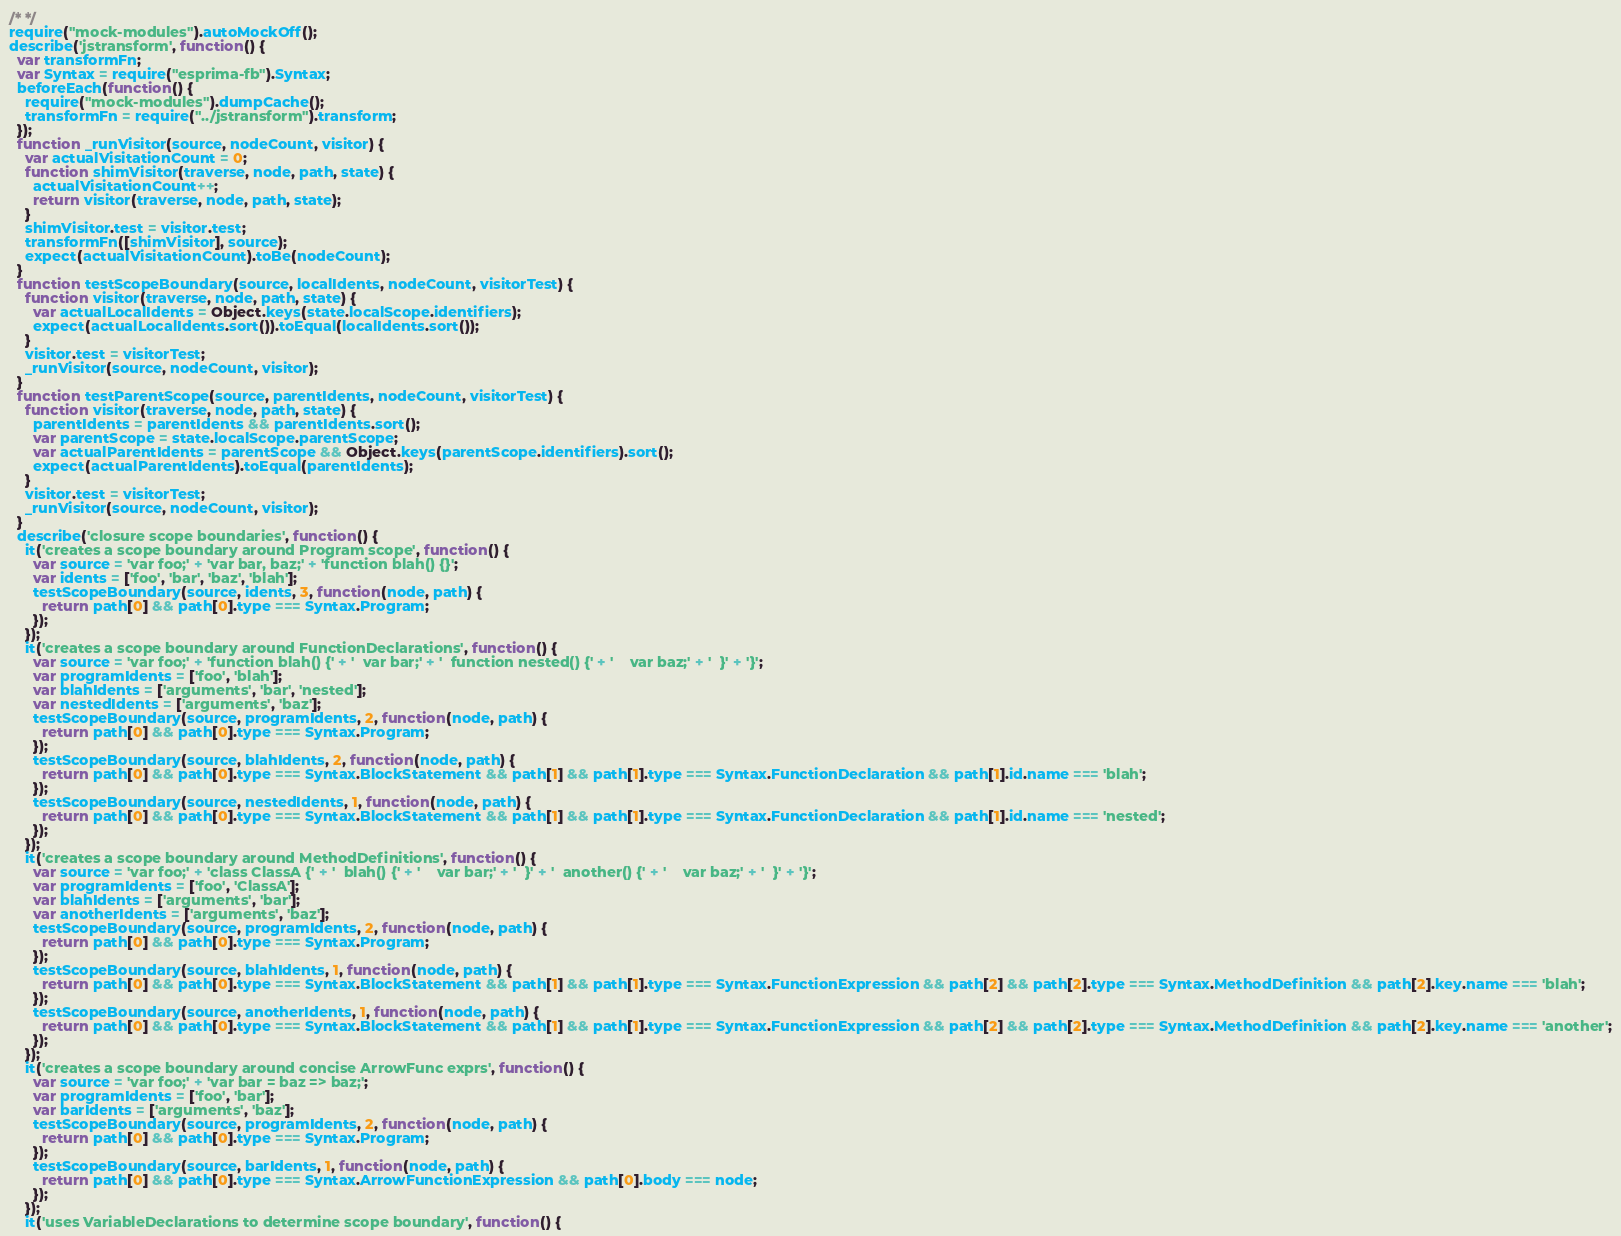Convert code to text. <code><loc_0><loc_0><loc_500><loc_500><_JavaScript_>/* */ 
require("mock-modules").autoMockOff();
describe('jstransform', function() {
  var transformFn;
  var Syntax = require("esprima-fb").Syntax;
  beforeEach(function() {
    require("mock-modules").dumpCache();
    transformFn = require("../jstransform").transform;
  });
  function _runVisitor(source, nodeCount, visitor) {
    var actualVisitationCount = 0;
    function shimVisitor(traverse, node, path, state) {
      actualVisitationCount++;
      return visitor(traverse, node, path, state);
    }
    shimVisitor.test = visitor.test;
    transformFn([shimVisitor], source);
    expect(actualVisitationCount).toBe(nodeCount);
  }
  function testScopeBoundary(source, localIdents, nodeCount, visitorTest) {
    function visitor(traverse, node, path, state) {
      var actualLocalIdents = Object.keys(state.localScope.identifiers);
      expect(actualLocalIdents.sort()).toEqual(localIdents.sort());
    }
    visitor.test = visitorTest;
    _runVisitor(source, nodeCount, visitor);
  }
  function testParentScope(source, parentIdents, nodeCount, visitorTest) {
    function visitor(traverse, node, path, state) {
      parentIdents = parentIdents && parentIdents.sort();
      var parentScope = state.localScope.parentScope;
      var actualParentIdents = parentScope && Object.keys(parentScope.identifiers).sort();
      expect(actualParentIdents).toEqual(parentIdents);
    }
    visitor.test = visitorTest;
    _runVisitor(source, nodeCount, visitor);
  }
  describe('closure scope boundaries', function() {
    it('creates a scope boundary around Program scope', function() {
      var source = 'var foo;' + 'var bar, baz;' + 'function blah() {}';
      var idents = ['foo', 'bar', 'baz', 'blah'];
      testScopeBoundary(source, idents, 3, function(node, path) {
        return path[0] && path[0].type === Syntax.Program;
      });
    });
    it('creates a scope boundary around FunctionDeclarations', function() {
      var source = 'var foo;' + 'function blah() {' + '  var bar;' + '  function nested() {' + '    var baz;' + '  }' + '}';
      var programIdents = ['foo', 'blah'];
      var blahIdents = ['arguments', 'bar', 'nested'];
      var nestedIdents = ['arguments', 'baz'];
      testScopeBoundary(source, programIdents, 2, function(node, path) {
        return path[0] && path[0].type === Syntax.Program;
      });
      testScopeBoundary(source, blahIdents, 2, function(node, path) {
        return path[0] && path[0].type === Syntax.BlockStatement && path[1] && path[1].type === Syntax.FunctionDeclaration && path[1].id.name === 'blah';
      });
      testScopeBoundary(source, nestedIdents, 1, function(node, path) {
        return path[0] && path[0].type === Syntax.BlockStatement && path[1] && path[1].type === Syntax.FunctionDeclaration && path[1].id.name === 'nested';
      });
    });
    it('creates a scope boundary around MethodDefinitions', function() {
      var source = 'var foo;' + 'class ClassA {' + '  blah() {' + '    var bar;' + '  }' + '  another() {' + '    var baz;' + '  }' + '}';
      var programIdents = ['foo', 'ClassA'];
      var blahIdents = ['arguments', 'bar'];
      var anotherIdents = ['arguments', 'baz'];
      testScopeBoundary(source, programIdents, 2, function(node, path) {
        return path[0] && path[0].type === Syntax.Program;
      });
      testScopeBoundary(source, blahIdents, 1, function(node, path) {
        return path[0] && path[0].type === Syntax.BlockStatement && path[1] && path[1].type === Syntax.FunctionExpression && path[2] && path[2].type === Syntax.MethodDefinition && path[2].key.name === 'blah';
      });
      testScopeBoundary(source, anotherIdents, 1, function(node, path) {
        return path[0] && path[0].type === Syntax.BlockStatement && path[1] && path[1].type === Syntax.FunctionExpression && path[2] && path[2].type === Syntax.MethodDefinition && path[2].key.name === 'another';
      });
    });
    it('creates a scope boundary around concise ArrowFunc exprs', function() {
      var source = 'var foo;' + 'var bar = baz => baz;';
      var programIdents = ['foo', 'bar'];
      var barIdents = ['arguments', 'baz'];
      testScopeBoundary(source, programIdents, 2, function(node, path) {
        return path[0] && path[0].type === Syntax.Program;
      });
      testScopeBoundary(source, barIdents, 1, function(node, path) {
        return path[0] && path[0].type === Syntax.ArrowFunctionExpression && path[0].body === node;
      });
    });
    it('uses VariableDeclarations to determine scope boundary', function() {</code> 